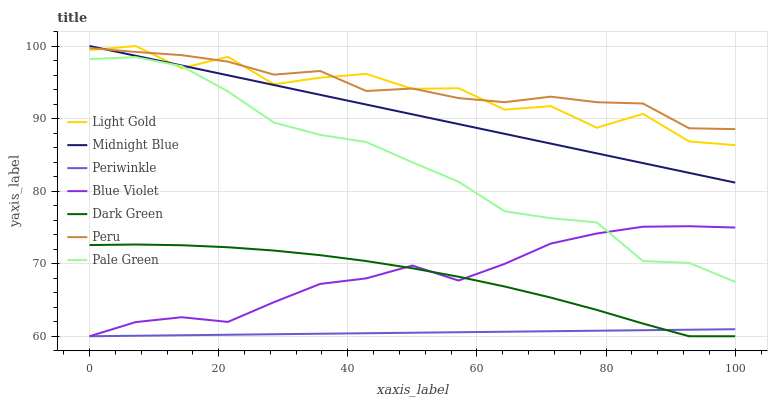Does Periwinkle have the minimum area under the curve?
Answer yes or no. Yes. Does Peru have the maximum area under the curve?
Answer yes or no. Yes. Does Pale Green have the minimum area under the curve?
Answer yes or no. No. Does Pale Green have the maximum area under the curve?
Answer yes or no. No. Is Periwinkle the smoothest?
Answer yes or no. Yes. Is Light Gold the roughest?
Answer yes or no. Yes. Is Pale Green the smoothest?
Answer yes or no. No. Is Pale Green the roughest?
Answer yes or no. No. Does Pale Green have the lowest value?
Answer yes or no. No. Does Light Gold have the highest value?
Answer yes or no. Yes. Does Pale Green have the highest value?
Answer yes or no. No. Is Pale Green less than Midnight Blue?
Answer yes or no. Yes. Is Peru greater than Pale Green?
Answer yes or no. Yes. Does Blue Violet intersect Periwinkle?
Answer yes or no. Yes. Is Blue Violet less than Periwinkle?
Answer yes or no. No. Is Blue Violet greater than Periwinkle?
Answer yes or no. No. Does Pale Green intersect Midnight Blue?
Answer yes or no. No. 